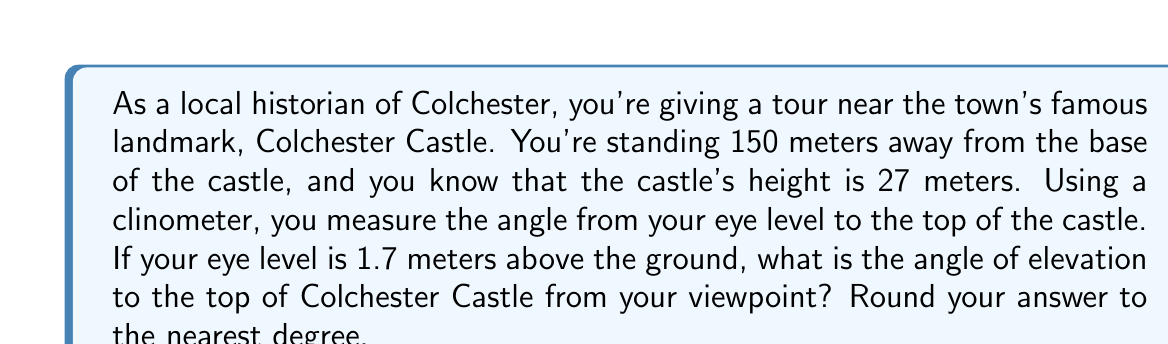Show me your answer to this math problem. To solve this problem, we need to use trigonometry, specifically the tangent function. Let's break it down step-by-step:

1. First, let's visualize the problem:

[asy]
import geometry;

pair A = (0,0);
pair B = (150,0);
pair C = (150,27);
pair D = (150,1.7);

draw(A--B--C--A);
draw(A--D,dashed);

label("150 m", (75,0), S);
label("27 m", (150,13.5), E);
label("1.7 m", (150,0.85), E);
label("θ", (10,5), NW);

dot("A", A, SW);
dot("B", B, SE);
dot("C", C, NE);
dot("D", D, E);
[/asy]

2. We need to find the angle θ. The tangent of this angle is the ratio of the opposite side to the adjacent side.

3. The opposite side is the height difference between the top of the castle and our eye level:
   $27 \text{ m} - 1.7 \text{ m} = 25.3 \text{ m}$

4. The adjacent side is the distance from our position to the base of the castle: 150 m

5. Now we can set up the tangent equation:

   $$\tan(\theta) = \frac{\text{opposite}}{\text{adjacent}} = \frac{25.3}{150}$$

6. To find θ, we need to use the inverse tangent (arctan or $\tan^{-1}$):

   $$\theta = \tan^{-1}\left(\frac{25.3}{150}\right)$$

7. Using a calculator:

   $$\theta = \tan^{-1}(0.16866...) \approx 9.57°$$

8. Rounding to the nearest degree:

   $$\theta \approx 10°$$
Answer: The angle of elevation to the top of Colchester Castle from the viewpoint is approximately 10°. 